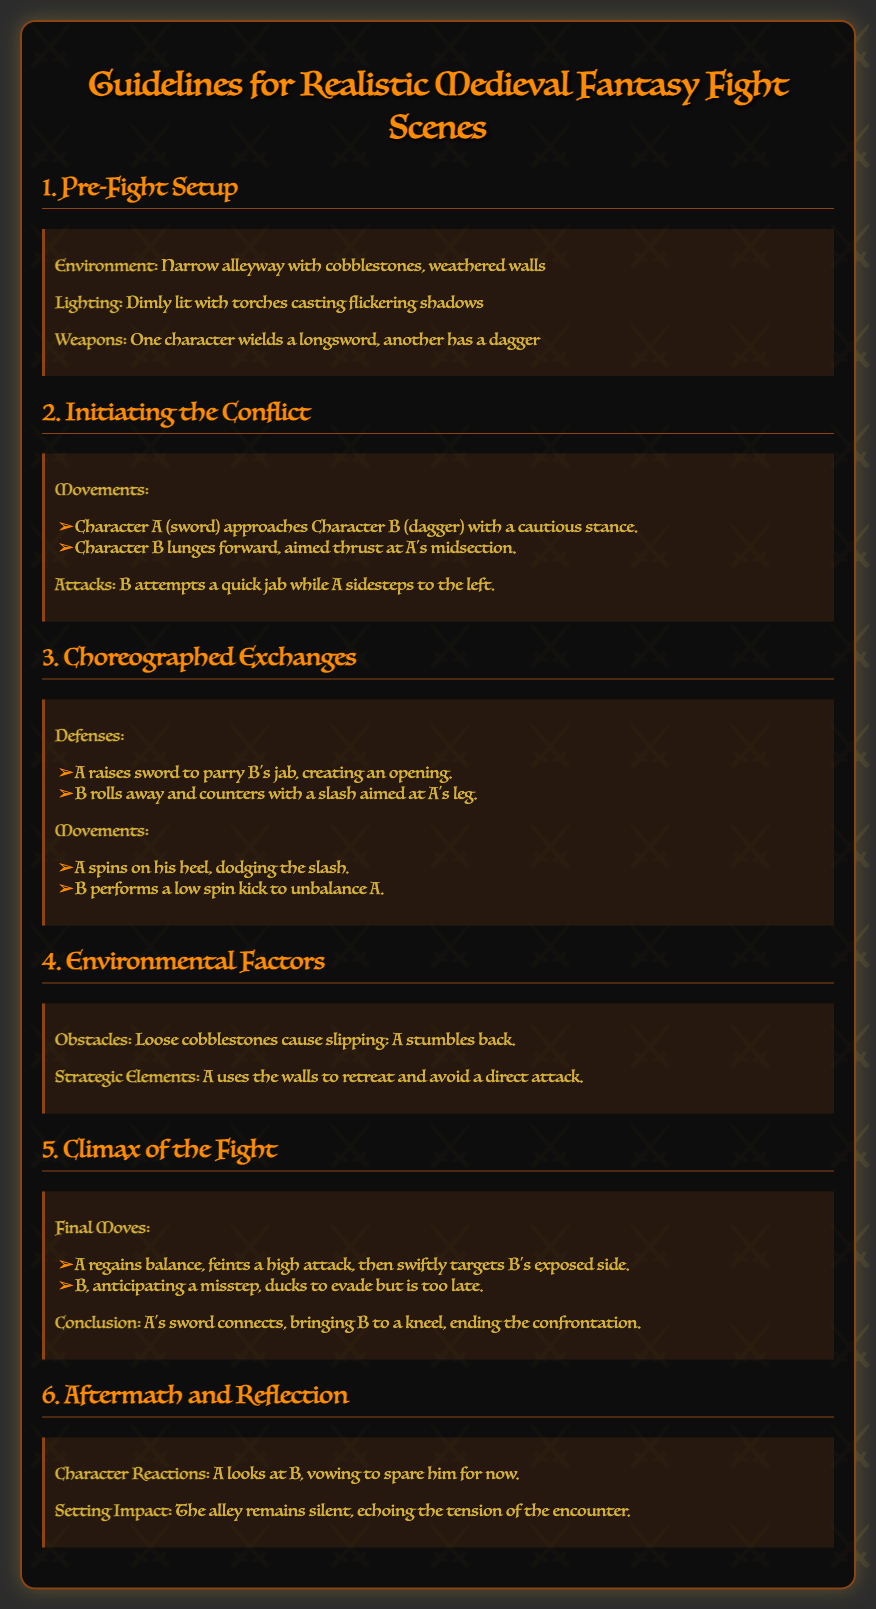What is the environment of the fight scene? The document specifies the fight scene takes place in a narrow alleyway with cobblestones and weathered walls.
Answer: Narrow alleyway with cobblestones, weathered walls How many characters are involved in the fight? The document mentions two characters, one with a longsword and the other with a dagger.
Answer: Two What weapon does Character A wield? Character A wields a longsword, as stated in the document.
Answer: Longsword What action does Character B attempt as the fight begins? Character B lunges forward aimed at Character A's midsection to initiate the conflict.
Answer: Aimed thrust What factors cause slipping during the fight? The loose cobblestones in the document cause slipping, which impacts the fight sequence.
Answer: Loose cobblestones Which character ultimately wins the fight? The conclusion mentions that Character A's sword connects with Character B, leading to victory.
Answer: Character A What strategic element does Character A use during the fight? Character A retreats using the walls as a strategic element to avoid direct attacks.
Answer: Walls What happens to Character B at the climax of the fight? Character B ducks to evade but is too late, which leads to him kneeling after the attack connects.
Answer: Kneels How does Character A feel after the confrontation? The document states Character A looks at Character B and vows to spare him for now, indicating a moment of reflection.
Answer: Vowing to spare him 